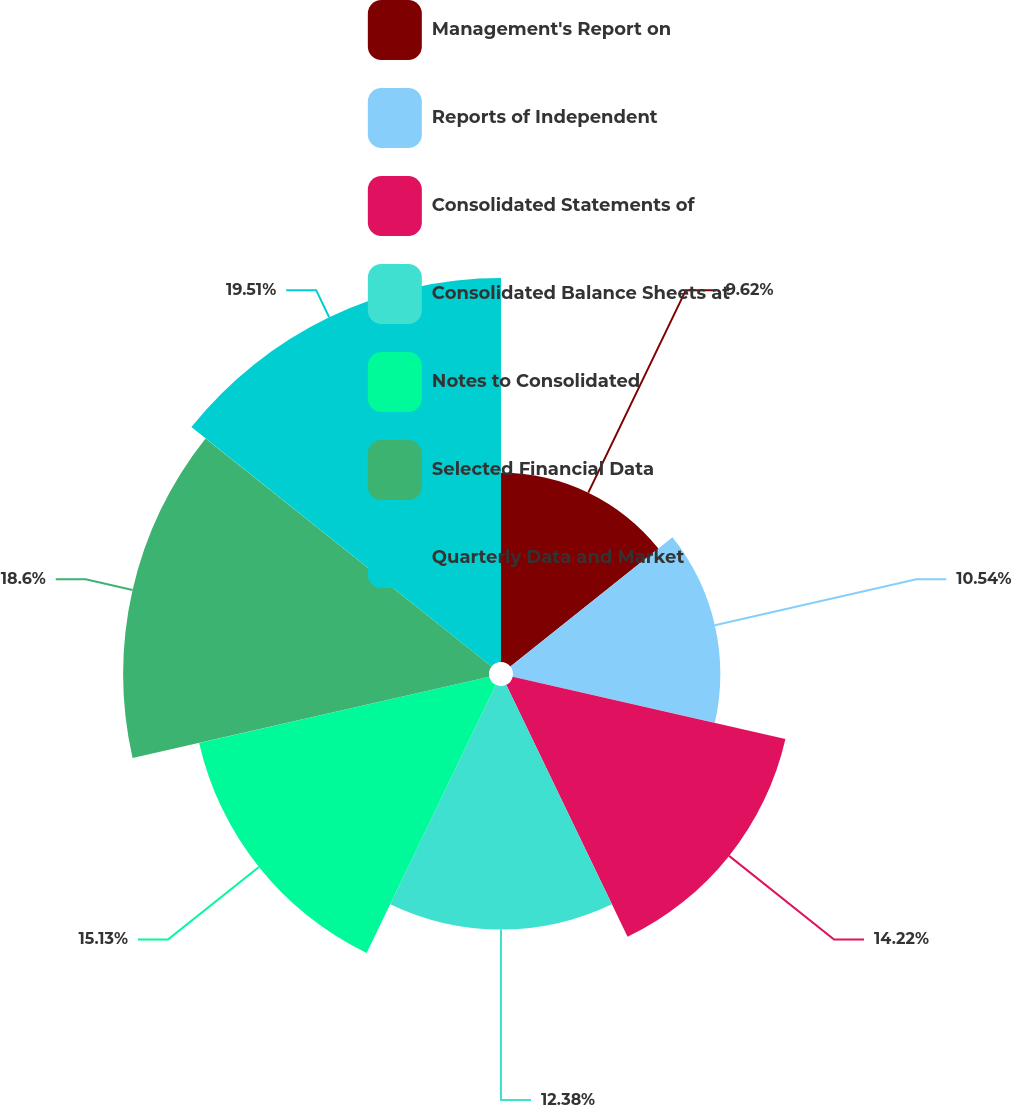Convert chart to OTSL. <chart><loc_0><loc_0><loc_500><loc_500><pie_chart><fcel>Management's Report on<fcel>Reports of Independent<fcel>Consolidated Statements of<fcel>Consolidated Balance Sheets at<fcel>Notes to Consolidated<fcel>Selected Financial Data<fcel>Quarterly Data and Market<nl><fcel>9.62%<fcel>10.54%<fcel>14.22%<fcel>12.38%<fcel>15.13%<fcel>18.6%<fcel>19.52%<nl></chart> 